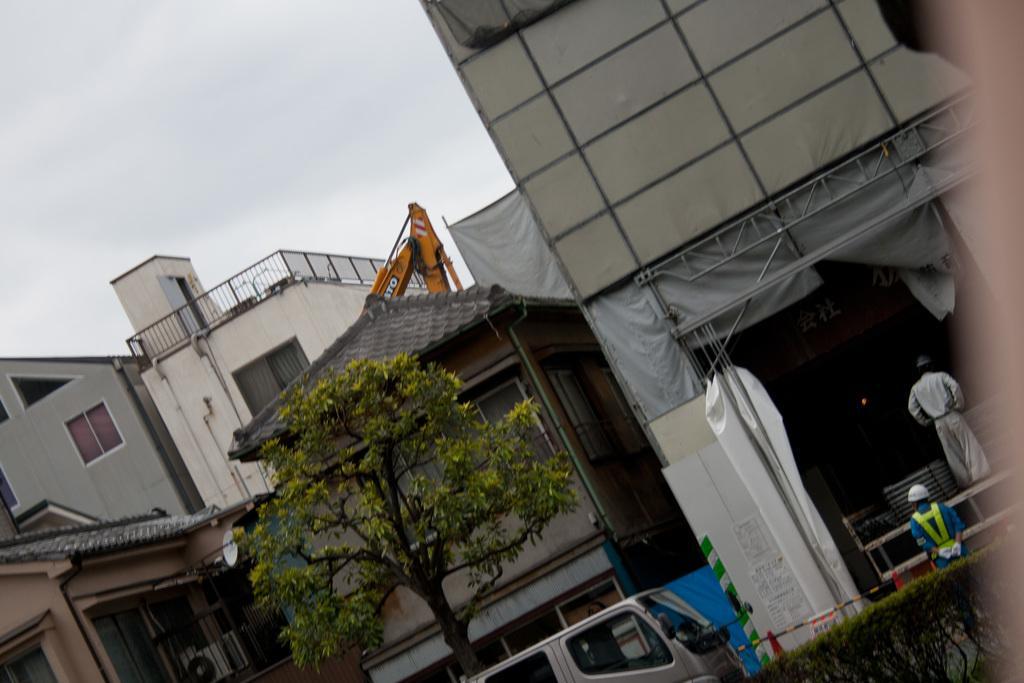In one or two sentences, can you explain what this image depicts? In this image, we can see buildings, a tree and there are vehicles. There are two people and are wearing caps, one of them is wearing a safety jacket and there are traffic cones and we can see plants. At the top, there is sky. 